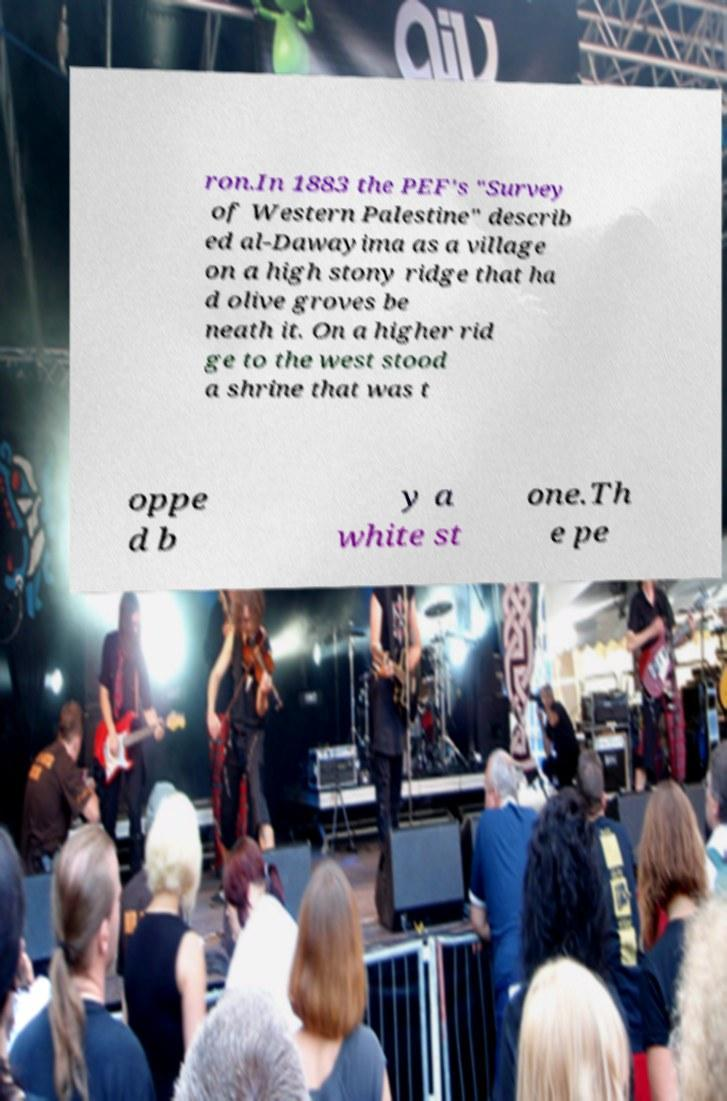For documentation purposes, I need the text within this image transcribed. Could you provide that? ron.In 1883 the PEF's "Survey of Western Palestine" describ ed al-Dawayima as a village on a high stony ridge that ha d olive groves be neath it. On a higher rid ge to the west stood a shrine that was t oppe d b y a white st one.Th e pe 